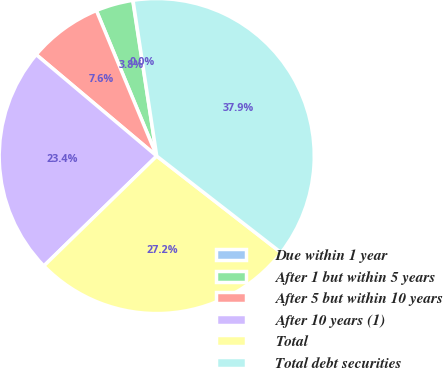Convert chart to OTSL. <chart><loc_0><loc_0><loc_500><loc_500><pie_chart><fcel>Due within 1 year<fcel>After 1 but within 5 years<fcel>After 5 but within 10 years<fcel>After 10 years (1)<fcel>Total<fcel>Total debt securities<nl><fcel>0.03%<fcel>3.82%<fcel>7.61%<fcel>23.42%<fcel>27.21%<fcel>37.92%<nl></chart> 